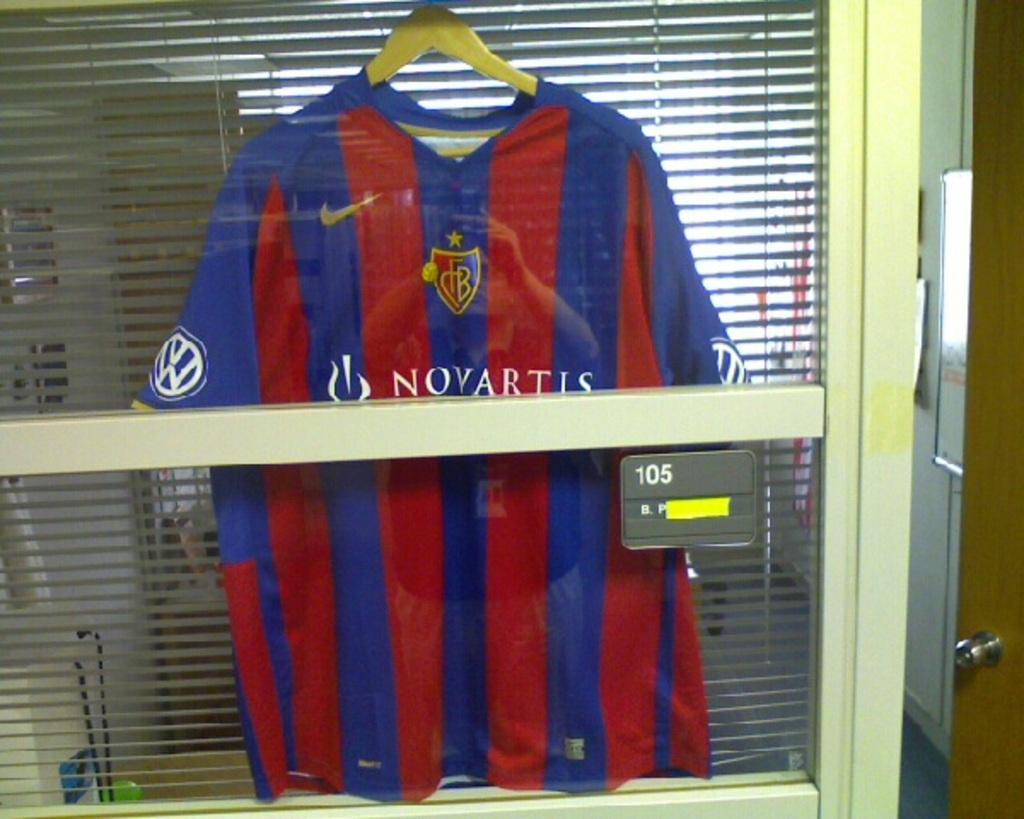What number is on the grey sign on the window?
Offer a terse response. 105. 